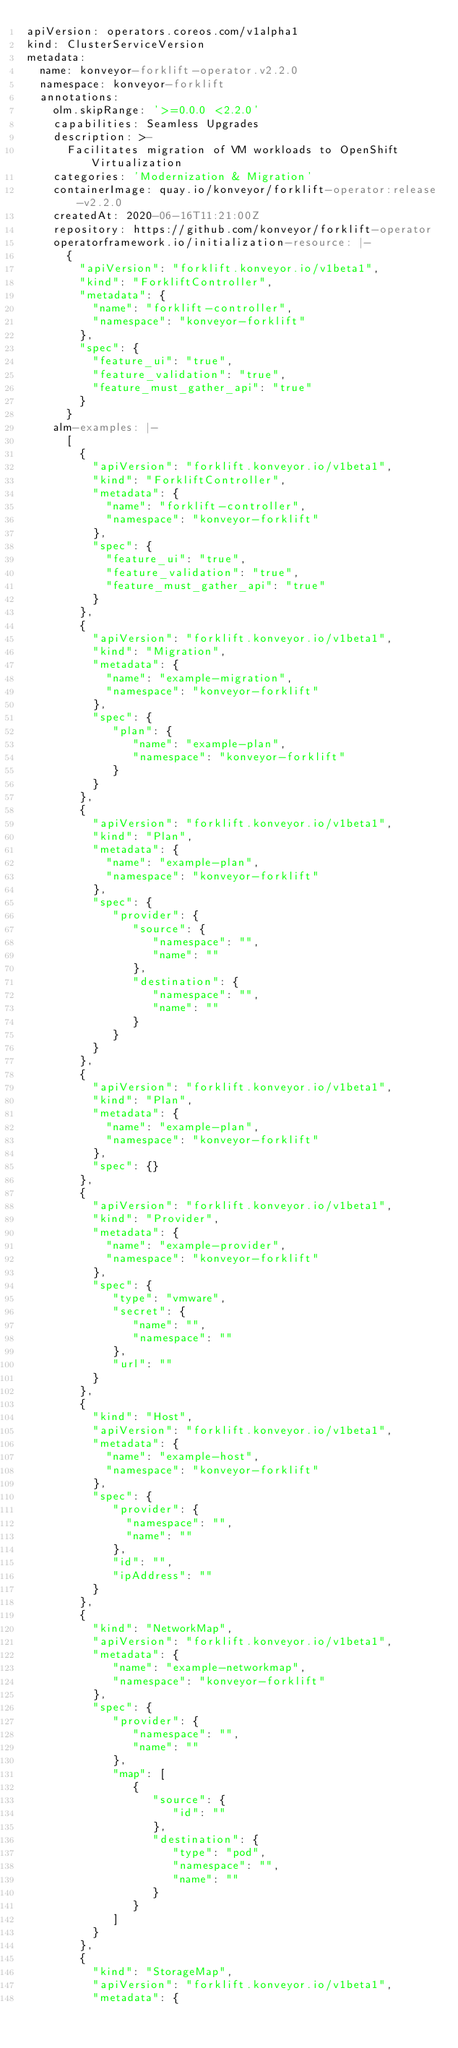Convert code to text. <code><loc_0><loc_0><loc_500><loc_500><_YAML_>apiVersion: operators.coreos.com/v1alpha1
kind: ClusterServiceVersion
metadata:
  name: konveyor-forklift-operator.v2.2.0
  namespace: konveyor-forklift
  annotations:
    olm.skipRange: '>=0.0.0 <2.2.0'
    capabilities: Seamless Upgrades
    description: >-
      Facilitates migration of VM workloads to OpenShift Virtualization
    categories: 'Modernization & Migration'
    containerImage: quay.io/konveyor/forklift-operator:release-v2.2.0
    createdAt: 2020-06-16T11:21:00Z
    repository: https://github.com/konveyor/forklift-operator
    operatorframework.io/initialization-resource: |-
      {
        "apiVersion": "forklift.konveyor.io/v1beta1",
        "kind": "ForkliftController",
        "metadata": {
          "name": "forklift-controller",
          "namespace": "konveyor-forklift"
        },
        "spec": {
          "feature_ui": "true",
          "feature_validation": "true",
          "feature_must_gather_api": "true"
        }
      }
    alm-examples: |-
      [
        {
          "apiVersion": "forklift.konveyor.io/v1beta1",
          "kind": "ForkliftController",
          "metadata": {
            "name": "forklift-controller",
            "namespace": "konveyor-forklift"
          },
          "spec": {
            "feature_ui": "true",
            "feature_validation": "true",
            "feature_must_gather_api": "true"
          }
        },
        {
          "apiVersion": "forklift.konveyor.io/v1beta1",
          "kind": "Migration",
          "metadata": {
            "name": "example-migration",
            "namespace": "konveyor-forklift"
          },
          "spec": {
             "plan": {
                "name": "example-plan",
                "namespace": "konveyor-forklift"
             }
          }
        },
        {
          "apiVersion": "forklift.konveyor.io/v1beta1",
          "kind": "Plan",
          "metadata": {
            "name": "example-plan",
            "namespace": "konveyor-forklift"
          },
          "spec": {
             "provider": {
                "source": {
                   "namespace": "",
                   "name": ""
                },
                "destination": {
                   "namespace": "",
                   "name": ""
                }
             }
          }
        },
        {
          "apiVersion": "forklift.konveyor.io/v1beta1",
          "kind": "Plan",
          "metadata": {
            "name": "example-plan",
            "namespace": "konveyor-forklift"
          },
          "spec": {}
        },
        {
          "apiVersion": "forklift.konveyor.io/v1beta1",
          "kind": "Provider",
          "metadata": {
            "name": "example-provider",
            "namespace": "konveyor-forklift"
          },
          "spec": {
             "type": "vmware",
             "secret": {
                "name": "",
                "namespace": ""
             },
             "url": ""
          }
        },
        {
          "kind": "Host",
          "apiVersion": "forklift.konveyor.io/v1beta1",
          "metadata": {
            "name": "example-host",
            "namespace": "konveyor-forklift"
          },
          "spec": {
             "provider": {
               "namespace": "",
               "name": ""
             },
             "id": "",
             "ipAddress": ""
          }
        },
        {
          "kind": "NetworkMap",
          "apiVersion": "forklift.konveyor.io/v1beta1",
          "metadata": {
             "name": "example-networkmap",
             "namespace": "konveyor-forklift"
          },
          "spec": {
             "provider": {
                "namespace": "",
                "name": ""
             },
             "map": [
                {
                   "source": {
                      "id": ""
                   },
                   "destination": {
                      "type": "pod",
                      "namespace": "",
                      "name": ""
                   }
                }
             ]
          }
        },
        {
          "kind": "StorageMap",
          "apiVersion": "forklift.konveyor.io/v1beta1",
          "metadata": {</code> 